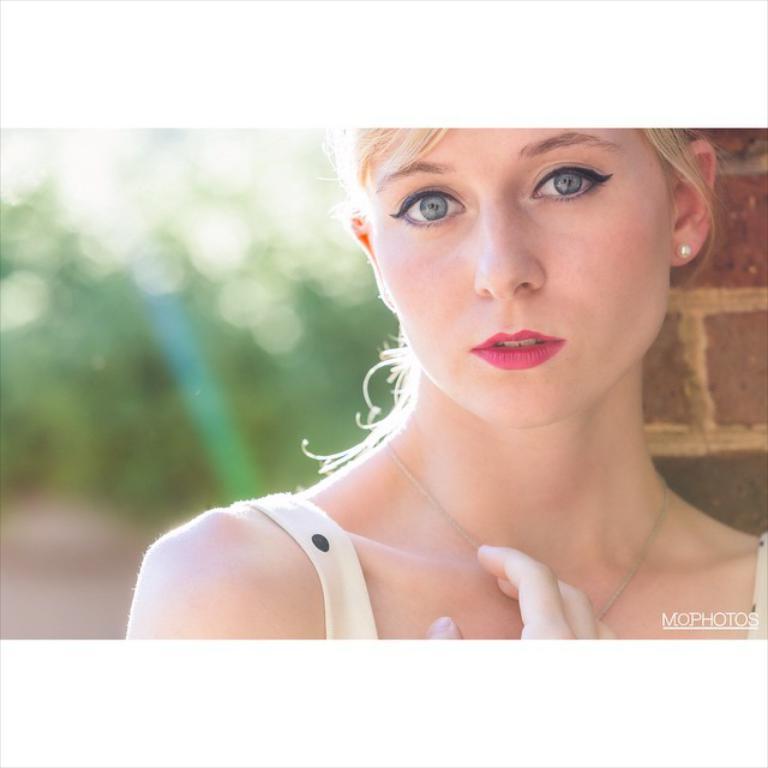In one or two sentences, can you explain what this image depicts? This is the woman. She wore a dress, necklace and earrings. This looks like a wall. The background looks blurry. I can see the watermark on the image. 